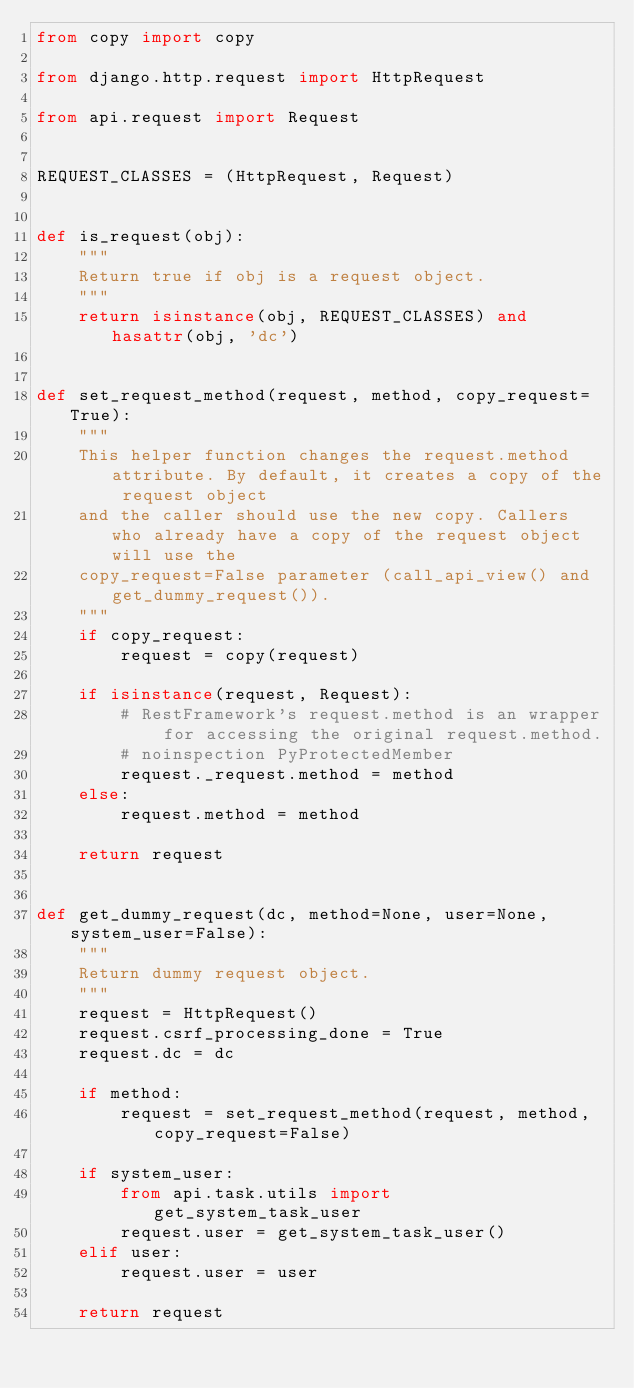<code> <loc_0><loc_0><loc_500><loc_500><_Python_>from copy import copy

from django.http.request import HttpRequest

from api.request import Request


REQUEST_CLASSES = (HttpRequest, Request)


def is_request(obj):
    """
    Return true if obj is a request object.
    """
    return isinstance(obj, REQUEST_CLASSES) and hasattr(obj, 'dc')


def set_request_method(request, method, copy_request=True):
    """
    This helper function changes the request.method attribute. By default, it creates a copy of the request object
    and the caller should use the new copy. Callers who already have a copy of the request object will use the
    copy_request=False parameter (call_api_view() and get_dummy_request()).
    """
    if copy_request:
        request = copy(request)

    if isinstance(request, Request):
        # RestFramework's request.method is an wrapper for accessing the original request.method.
        # noinspection PyProtectedMember
        request._request.method = method
    else:
        request.method = method

    return request


def get_dummy_request(dc, method=None, user=None, system_user=False):
    """
    Return dummy request object.
    """
    request = HttpRequest()
    request.csrf_processing_done = True
    request.dc = dc

    if method:
        request = set_request_method(request, method, copy_request=False)

    if system_user:
        from api.task.utils import get_system_task_user
        request.user = get_system_task_user()
    elif user:
        request.user = user

    return request
</code> 